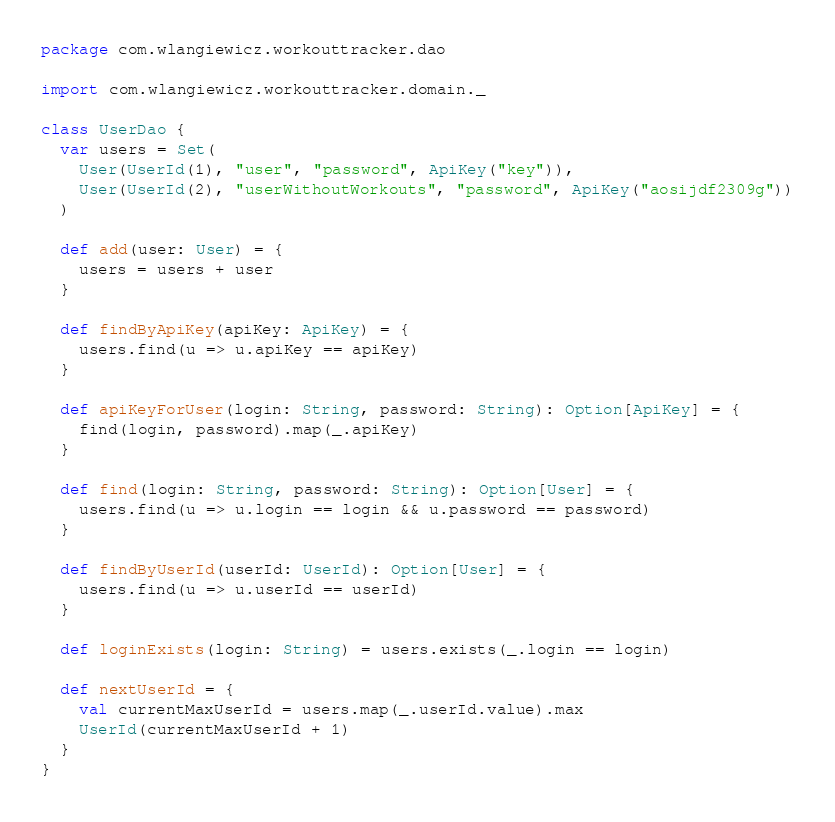<code> <loc_0><loc_0><loc_500><loc_500><_Scala_>package com.wlangiewicz.workouttracker.dao

import com.wlangiewicz.workouttracker.domain._

class UserDao {
  var users = Set(
    User(UserId(1), "user", "password", ApiKey("key")),
    User(UserId(2), "userWithoutWorkouts", "password", ApiKey("aosijdf2309g"))
  )

  def add(user: User) = {
    users = users + user
  }

  def findByApiKey(apiKey: ApiKey) = {
    users.find(u => u.apiKey == apiKey)
  }

  def apiKeyForUser(login: String, password: String): Option[ApiKey] = {
    find(login, password).map(_.apiKey)
  }

  def find(login: String, password: String): Option[User] = {
    users.find(u => u.login == login && u.password == password)
  }

  def findByUserId(userId: UserId): Option[User] = {
    users.find(u => u.userId == userId)
  }

  def loginExists(login: String) = users.exists(_.login == login)

  def nextUserId = {
    val currentMaxUserId = users.map(_.userId.value).max
    UserId(currentMaxUserId + 1)
  }
}
</code> 